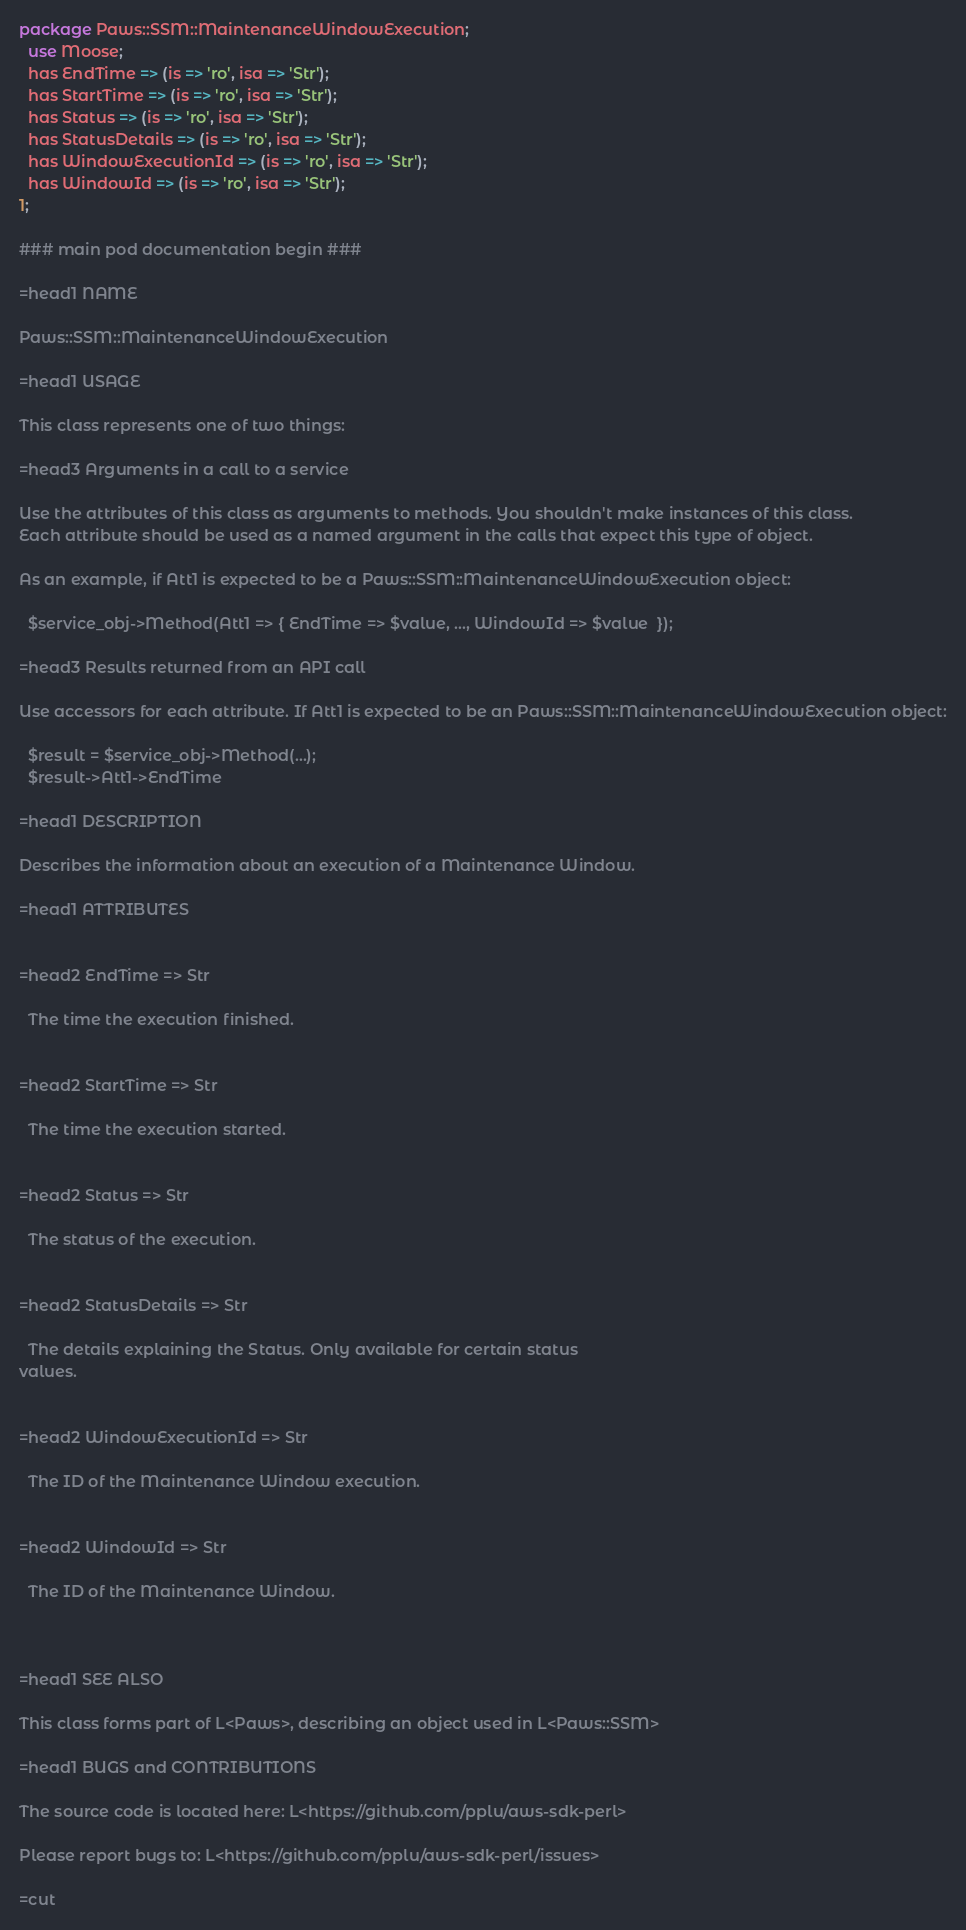<code> <loc_0><loc_0><loc_500><loc_500><_Perl_>package Paws::SSM::MaintenanceWindowExecution;
  use Moose;
  has EndTime => (is => 'ro', isa => 'Str');
  has StartTime => (is => 'ro', isa => 'Str');
  has Status => (is => 'ro', isa => 'Str');
  has StatusDetails => (is => 'ro', isa => 'Str');
  has WindowExecutionId => (is => 'ro', isa => 'Str');
  has WindowId => (is => 'ro', isa => 'Str');
1;

### main pod documentation begin ###

=head1 NAME

Paws::SSM::MaintenanceWindowExecution

=head1 USAGE

This class represents one of two things:

=head3 Arguments in a call to a service

Use the attributes of this class as arguments to methods. You shouldn't make instances of this class. 
Each attribute should be used as a named argument in the calls that expect this type of object.

As an example, if Att1 is expected to be a Paws::SSM::MaintenanceWindowExecution object:

  $service_obj->Method(Att1 => { EndTime => $value, ..., WindowId => $value  });

=head3 Results returned from an API call

Use accessors for each attribute. If Att1 is expected to be an Paws::SSM::MaintenanceWindowExecution object:

  $result = $service_obj->Method(...);
  $result->Att1->EndTime

=head1 DESCRIPTION

Describes the information about an execution of a Maintenance Window.

=head1 ATTRIBUTES


=head2 EndTime => Str

  The time the execution finished.


=head2 StartTime => Str

  The time the execution started.


=head2 Status => Str

  The status of the execution.


=head2 StatusDetails => Str

  The details explaining the Status. Only available for certain status
values.


=head2 WindowExecutionId => Str

  The ID of the Maintenance Window execution.


=head2 WindowId => Str

  The ID of the Maintenance Window.



=head1 SEE ALSO

This class forms part of L<Paws>, describing an object used in L<Paws::SSM>

=head1 BUGS and CONTRIBUTIONS

The source code is located here: L<https://github.com/pplu/aws-sdk-perl>

Please report bugs to: L<https://github.com/pplu/aws-sdk-perl/issues>

=cut

</code> 